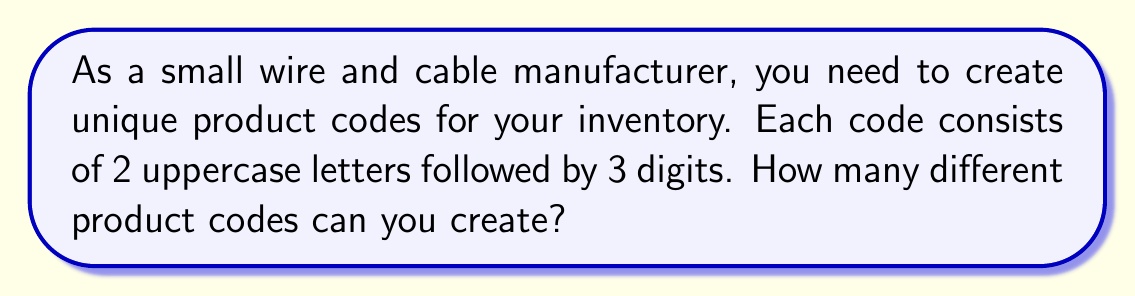Teach me how to tackle this problem. Let's break this down step-by-step:

1. For the first part of the code (2 uppercase letters):
   - There are 26 choices for each letter
   - We can use the multiplication principle: $26 \times 26 = 676$ possible letter combinations

2. For the second part of the code (3 digits):
   - There are 10 choices for each digit (0-9)
   - Again, using the multiplication principle: $10 \times 10 \times 10 = 1000$ possible digit combinations

3. To get the total number of unique codes, we multiply the number of possibilities for each part:
   $$ 676 \times 1000 = 676,000 $$

Therefore, the total number of unique product codes is 676,000.

Alternatively, we can express this using exponents:
$$ 26^2 \times 10^3 = 676,000 $$
Answer: 676,000 